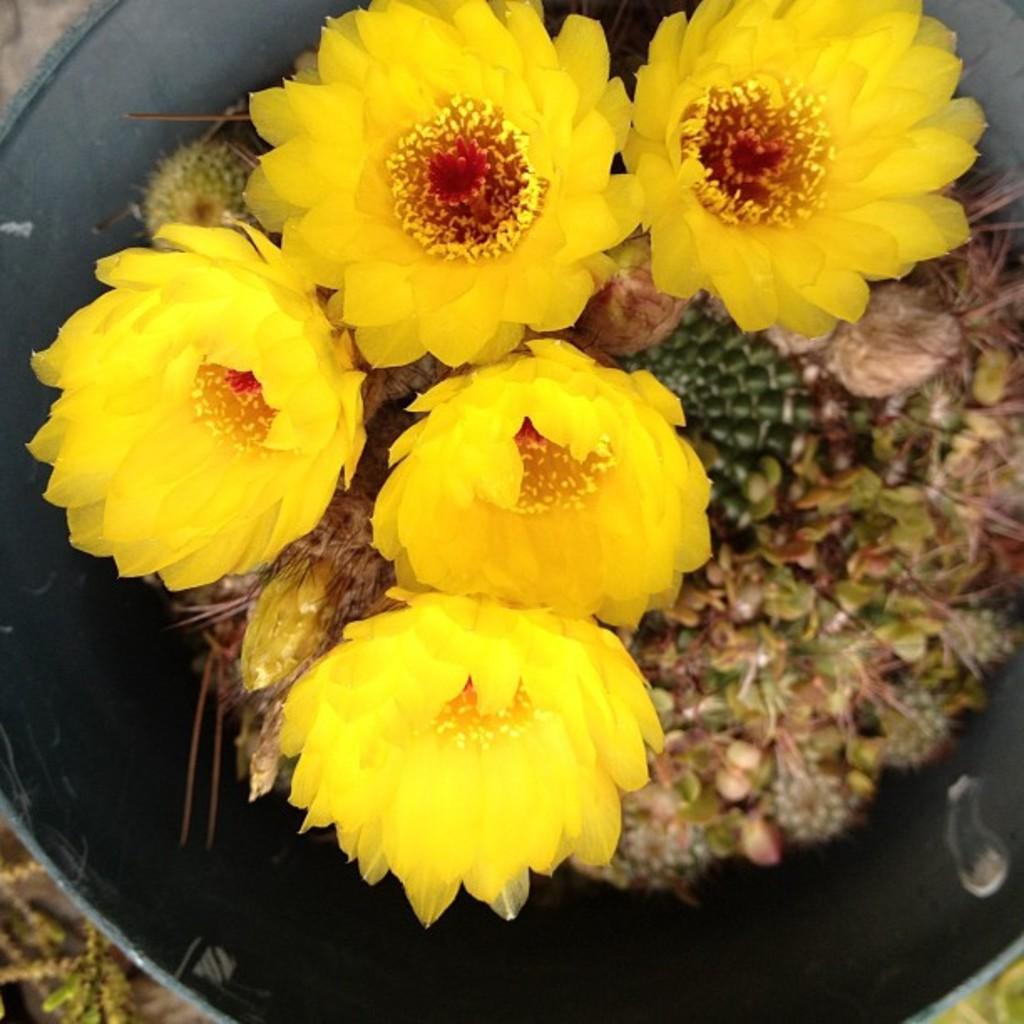Please provide a concise description of this image. In this picture there are yellow color flowers in the image. 